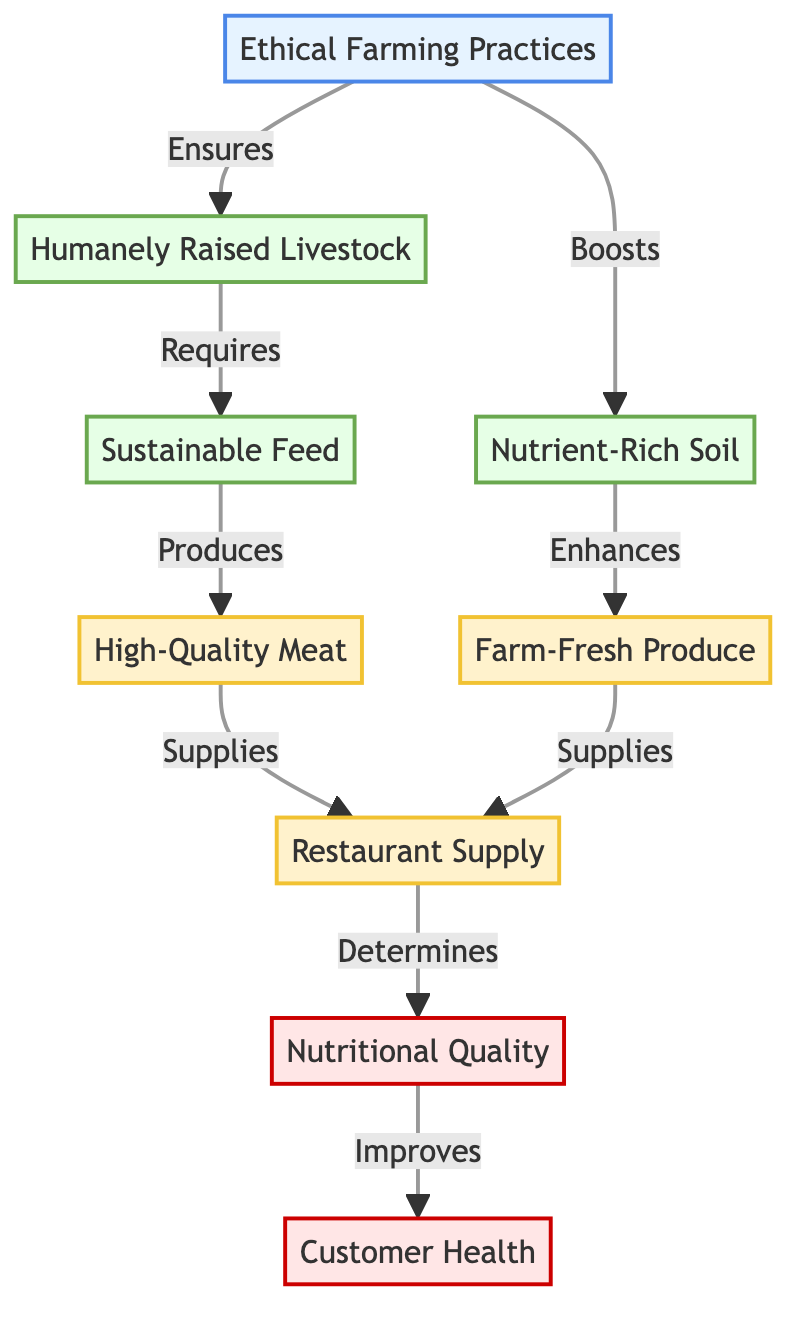What's the first node in the flow? The first node in the flow is "Ethical Farming Practices," which is the starting point that influences other aspects of the diagram.
Answer: Ethical Farming Practices How many input nodes are present? There are three input nodes: "Nutrient-Rich Soil," "Humanely Raised Livestock," and "Sustainable Feed." Counting each, the total is three.
Answer: 3 What does "Humanely Raised Livestock" require? According to the diagram, "Humanely Raised Livestock" requires "Sustainable Feed," which is necessary to support the health and well-being of the animals.
Answer: Sustainable Feed Which nodes supply the "Restaurant Supply"? The nodes that supply "Restaurant Supply" are "High-Quality Meat" and "Farm-Fresh Produce," indicating that both these outputs contribute to the supply chain of the restaurant.
Answer: High-Quality Meat; Farm-Fresh Produce How does "Nutritional Quality" improve "Customer Health"? "Nutritional Quality" improves "Customer Health" as indicated in the flow; the increase in quality of the food provided leads to better health outcomes for customers that consume it.
Answer: Improves What is the relationship between "Nutrient-Rich Soil" and "Farm-Fresh Produce"? The relationship is that "Nutrient-Rich Soil" enhances "Farm-Fresh Produce," meaning the quality of the soil directly contributes to the quality of the produce grown.
Answer: Enhances Which node is influenced by both "Farm-Fresh Produce" and "High-Quality Meat"? The node influenced by both "Farm-Fresh Produce" and "High-Quality Meat" is "Restaurant Supply," indicating that both types of food contribute to the supply for the restaurant.
Answer: Restaurant Supply What boosts "Nutrient-Rich Soil"? The diagram states that "Ethical Farming Practices" boost "Nutrient-Rich Soil," showing the positive impact of farming methods on soil health.
Answer: Boosts What is the final output related to "Customer Health"? The final output related to "Customer Health" is determined by "Nutritional Quality," showing that the quality of the nutrition is crucial for health benefits.
Answer: Nutritional Quality 